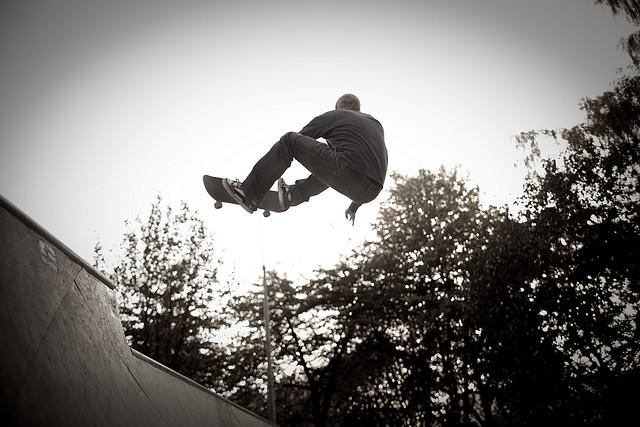How did the man get in the air?
Write a very short answer. Jumped. What is the man standing on?
Concise answer only. Skateboard. Is this photo greyscale?
Be succinct. Yes. 